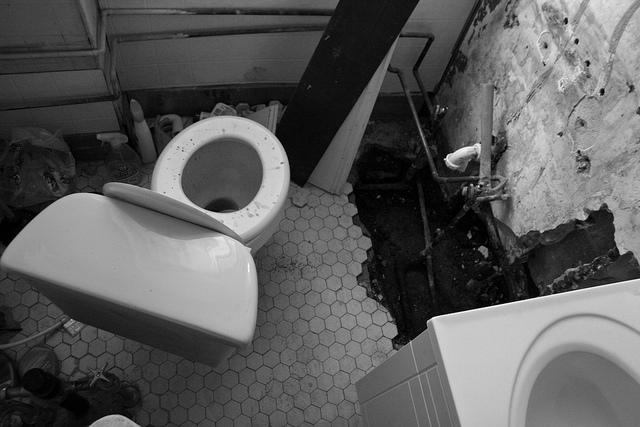What usually goes inside of the item with the lid? human waste 